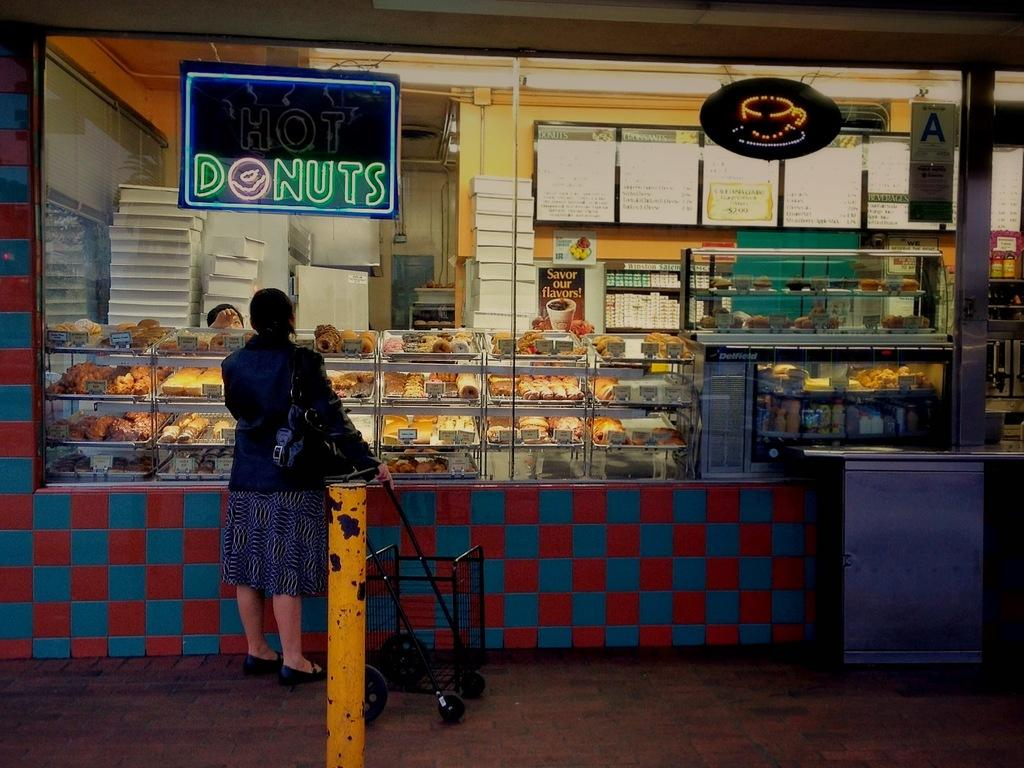Provide a one-sentence caption for the provided image. A neon sign advertising donuts hangs in front of a food business. 